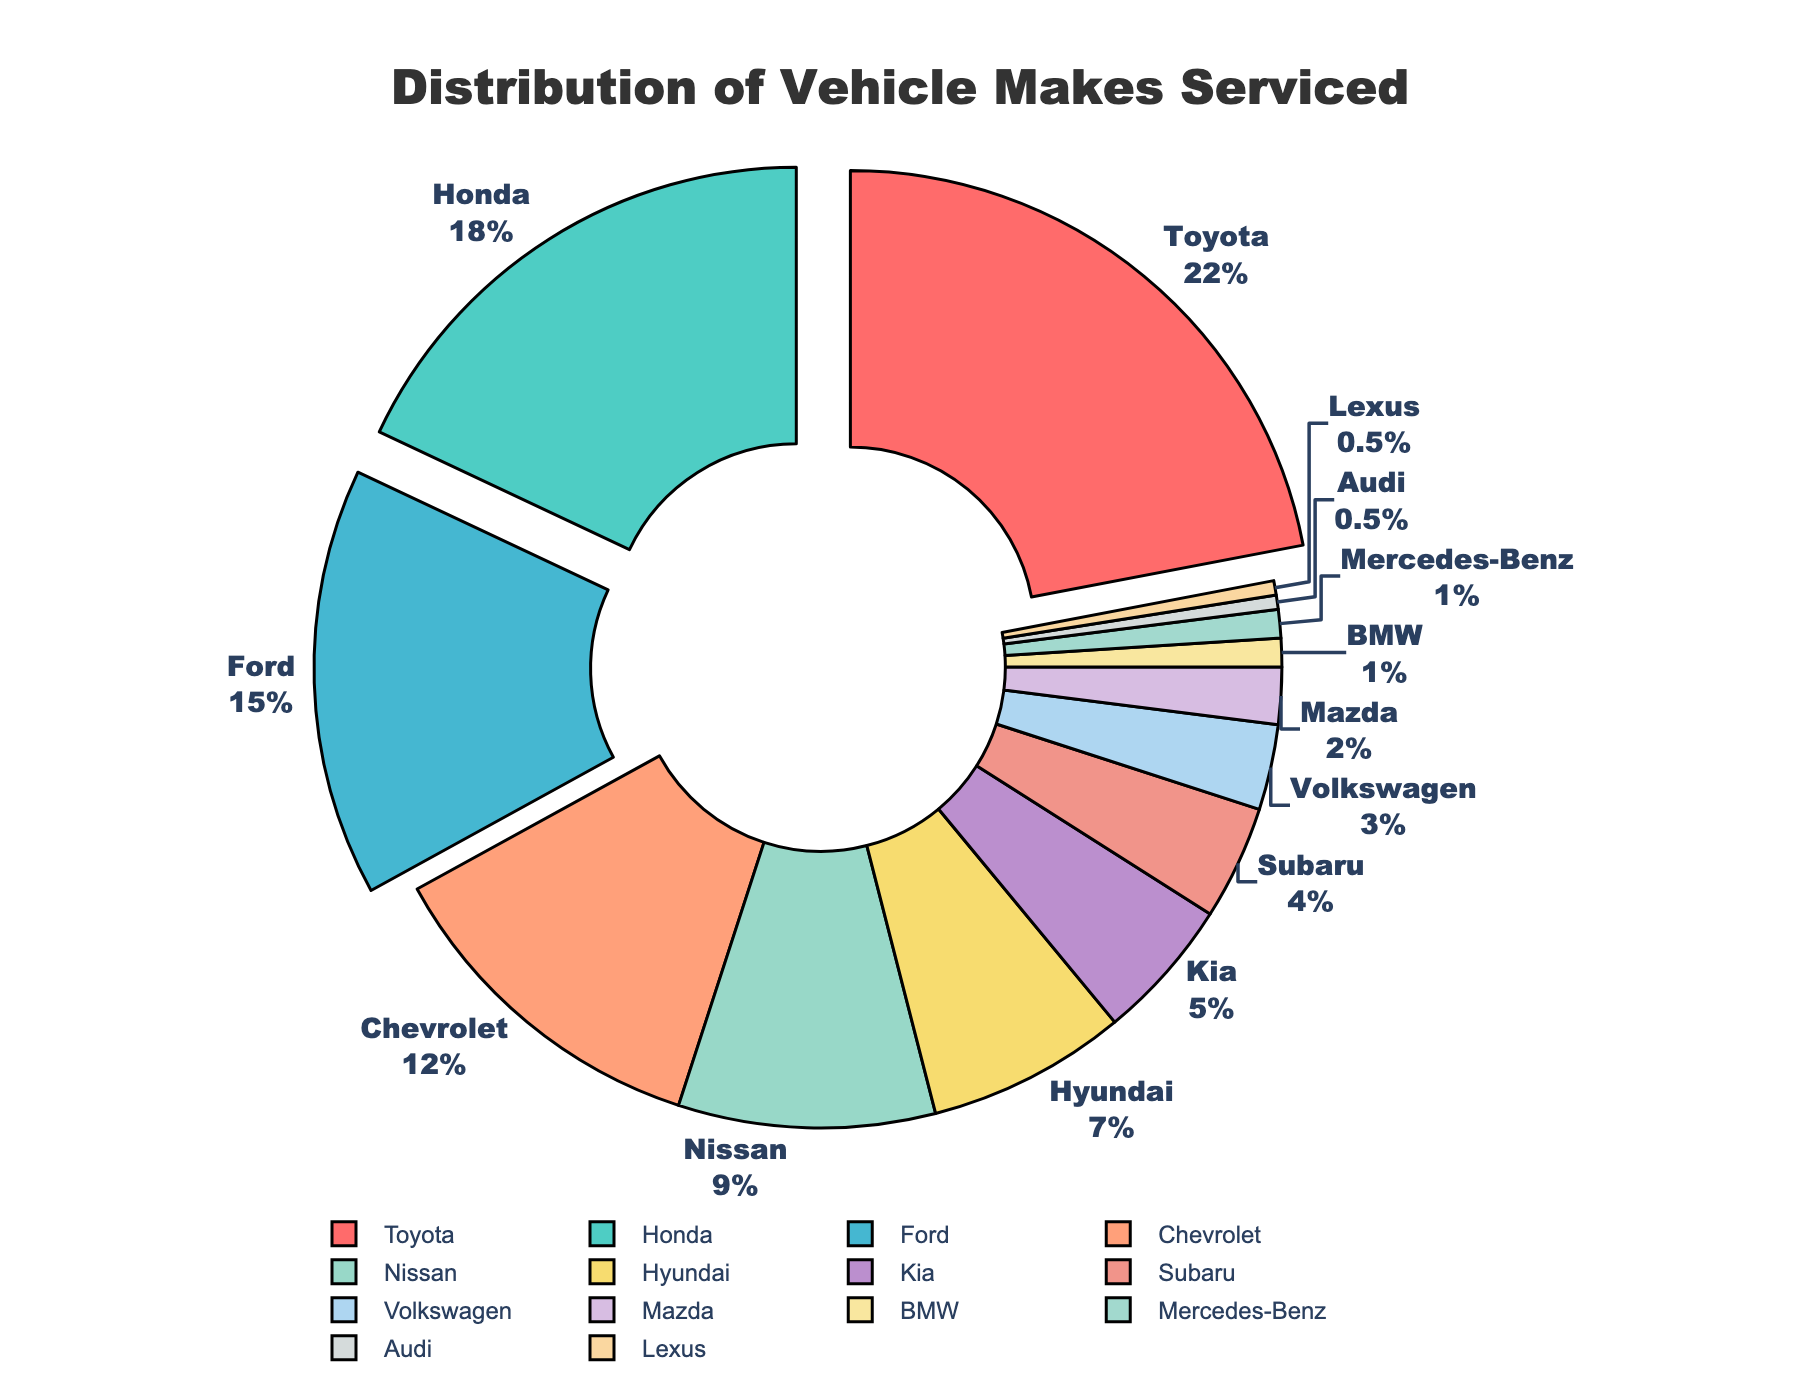What is the percentage of Toyota vehicles serviced in the shop? The pie chart shows that Toyota vehicles make up 22% of the total vehicles serviced in the shop.
Answer: 22% What are the top three makes of vehicles serviced, and what percentage do they represent collectively? The top three makes are Toyota (22%), Honda (18%), and Ford (15%). Summing these percentages together: 22 + 18 + 15 = 55%.
Answer: 55% Which vehicle make represents the smallest percentage serviced, and what is its percentage? The pie chart shows that both Audi and Lexus make up the smallest percentage, each contributing 0.5%.
Answer: Audi and Lexus, 0.5% How much more popular is servicing Toyota vehicles compared to servicing Chevrolet vehicles? Toyota vehicles are at 22% and Chevrolet vehicles are at 12%. The difference between them is 22% - 12% = 10%.
Answer: 10% What is the combined percentage of vehicles serviced that are either Kia or Hyundai? Kia makes up 5% and Hyundai makes up 7%. Summing them: 5 + 7 = 12%.
Answer: 12% Which make of vehicles is represented by a red section in the pie chart, and what is its percentage? The pie chart shows that the red section corresponds to Toyota vehicles, which make up 22% of the vehicles serviced.
Answer: Toyota, 22% Is the percentage of Nissan vehicles serviced greater than the percentage of Hyundai vehicles serviced? The pie chart shows that Nissan vehicles are 9% and Hyundai vehicles are 7%. 9% is greater than 7%, so the answer is yes.
Answer: Yes How does the combined percentage of vehicles serviced for BMW, Mercedes-Benz, Audi, and Lexus compare to Subaru alone? Combining BMW (1%), Mercedes-Benz (1%), Audi (0.5%), and Lexus (0.5%) results in 1 + 1 + 0.5 + 0.5 = 3%. Subaru alone is 4%. 3% is less than 4%.
Answer: Less Which three vehicle makes are pulled out in the pie chart, and why might this be the case? The pie chart pulls out Toyota, Honda, and Ford. This emphasizes their higher percentages of service rates: 22%, 18%, and 15%, respectively.
Answer: Toyota, Honda, Ford What is the total percentage of all vehicle makes serviced that are not part of the top five (i.e., Toyota, Honda, Ford, Chevrolet, Nissan)? The top five makes add up to: 22 + 18 + 15 + 12 + 9 = 76%. Therefore, the remaining percentage is: 100 - 76 = 24%.
Answer: 24% 